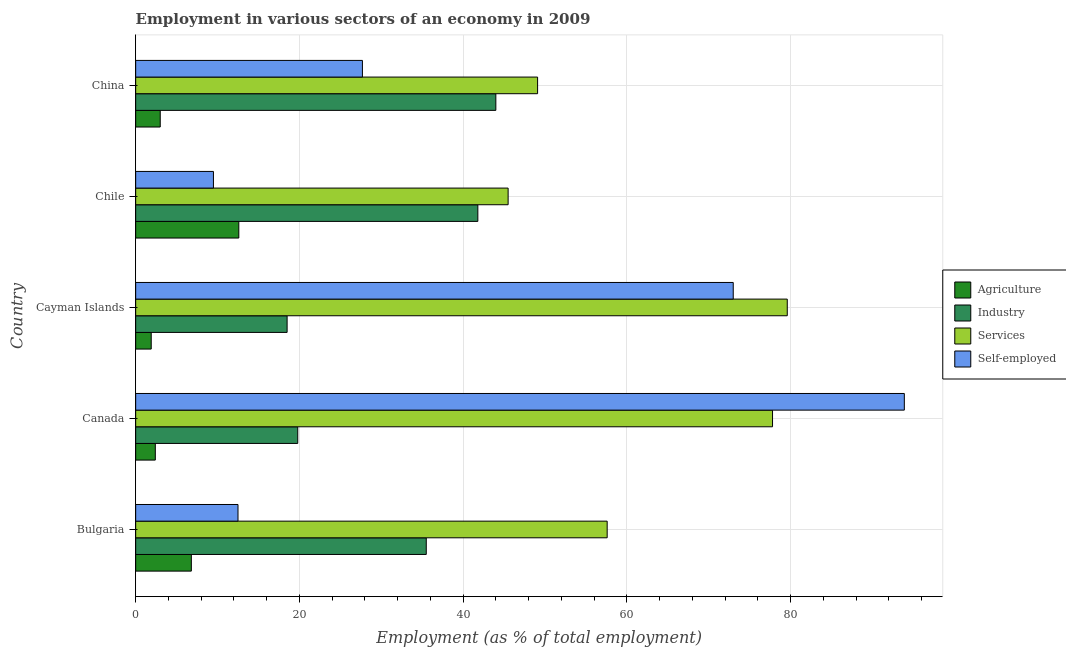How many groups of bars are there?
Offer a very short reply. 5. How many bars are there on the 3rd tick from the top?
Provide a succinct answer. 4. How many bars are there on the 2nd tick from the bottom?
Provide a succinct answer. 4. In how many cases, is the number of bars for a given country not equal to the number of legend labels?
Make the answer very short. 0. What is the percentage of workers in industry in China?
Offer a very short reply. 44. Across all countries, what is the maximum percentage of workers in services?
Your answer should be compact. 79.6. Across all countries, what is the minimum percentage of workers in agriculture?
Provide a succinct answer. 1.9. What is the total percentage of self employed workers in the graph?
Make the answer very short. 216.6. What is the difference between the percentage of workers in industry in Bulgaria and the percentage of self employed workers in Canada?
Offer a terse response. -58.4. What is the average percentage of workers in industry per country?
Your answer should be compact. 31.92. What is the difference between the percentage of workers in agriculture and percentage of self employed workers in Canada?
Your response must be concise. -91.5. What is the ratio of the percentage of self employed workers in Bulgaria to that in China?
Offer a very short reply. 0.45. Is the difference between the percentage of workers in industry in Cayman Islands and China greater than the difference between the percentage of workers in agriculture in Cayman Islands and China?
Make the answer very short. No. In how many countries, is the percentage of workers in industry greater than the average percentage of workers in industry taken over all countries?
Make the answer very short. 3. Is the sum of the percentage of workers in services in Bulgaria and Canada greater than the maximum percentage of workers in agriculture across all countries?
Provide a short and direct response. Yes. Is it the case that in every country, the sum of the percentage of workers in services and percentage of self employed workers is greater than the sum of percentage of workers in industry and percentage of workers in agriculture?
Make the answer very short. Yes. What does the 1st bar from the top in Cayman Islands represents?
Your answer should be very brief. Self-employed. What does the 3rd bar from the bottom in Bulgaria represents?
Your answer should be compact. Services. How many bars are there?
Offer a very short reply. 20. How many countries are there in the graph?
Offer a terse response. 5. How many legend labels are there?
Offer a very short reply. 4. What is the title of the graph?
Keep it short and to the point. Employment in various sectors of an economy in 2009. What is the label or title of the X-axis?
Offer a terse response. Employment (as % of total employment). What is the Employment (as % of total employment) in Agriculture in Bulgaria?
Make the answer very short. 6.8. What is the Employment (as % of total employment) of Industry in Bulgaria?
Offer a very short reply. 35.5. What is the Employment (as % of total employment) in Services in Bulgaria?
Your answer should be compact. 57.6. What is the Employment (as % of total employment) in Self-employed in Bulgaria?
Keep it short and to the point. 12.5. What is the Employment (as % of total employment) in Agriculture in Canada?
Provide a short and direct response. 2.4. What is the Employment (as % of total employment) in Industry in Canada?
Make the answer very short. 19.8. What is the Employment (as % of total employment) of Services in Canada?
Your answer should be compact. 77.8. What is the Employment (as % of total employment) in Self-employed in Canada?
Offer a terse response. 93.9. What is the Employment (as % of total employment) in Agriculture in Cayman Islands?
Provide a succinct answer. 1.9. What is the Employment (as % of total employment) of Services in Cayman Islands?
Your answer should be compact. 79.6. What is the Employment (as % of total employment) of Agriculture in Chile?
Your answer should be very brief. 12.6. What is the Employment (as % of total employment) in Industry in Chile?
Provide a short and direct response. 41.8. What is the Employment (as % of total employment) of Services in Chile?
Offer a terse response. 45.5. What is the Employment (as % of total employment) of Industry in China?
Ensure brevity in your answer.  44. What is the Employment (as % of total employment) of Services in China?
Make the answer very short. 49.1. What is the Employment (as % of total employment) in Self-employed in China?
Provide a succinct answer. 27.7. Across all countries, what is the maximum Employment (as % of total employment) of Agriculture?
Make the answer very short. 12.6. Across all countries, what is the maximum Employment (as % of total employment) in Services?
Make the answer very short. 79.6. Across all countries, what is the maximum Employment (as % of total employment) of Self-employed?
Provide a short and direct response. 93.9. Across all countries, what is the minimum Employment (as % of total employment) in Agriculture?
Offer a very short reply. 1.9. Across all countries, what is the minimum Employment (as % of total employment) in Industry?
Offer a very short reply. 18.5. Across all countries, what is the minimum Employment (as % of total employment) of Services?
Provide a short and direct response. 45.5. What is the total Employment (as % of total employment) of Agriculture in the graph?
Make the answer very short. 26.7. What is the total Employment (as % of total employment) in Industry in the graph?
Offer a terse response. 159.6. What is the total Employment (as % of total employment) in Services in the graph?
Give a very brief answer. 309.6. What is the total Employment (as % of total employment) of Self-employed in the graph?
Offer a terse response. 216.6. What is the difference between the Employment (as % of total employment) in Agriculture in Bulgaria and that in Canada?
Ensure brevity in your answer.  4.4. What is the difference between the Employment (as % of total employment) of Industry in Bulgaria and that in Canada?
Keep it short and to the point. 15.7. What is the difference between the Employment (as % of total employment) in Services in Bulgaria and that in Canada?
Offer a terse response. -20.2. What is the difference between the Employment (as % of total employment) of Self-employed in Bulgaria and that in Canada?
Your answer should be very brief. -81.4. What is the difference between the Employment (as % of total employment) of Self-employed in Bulgaria and that in Cayman Islands?
Keep it short and to the point. -60.5. What is the difference between the Employment (as % of total employment) of Industry in Bulgaria and that in Chile?
Give a very brief answer. -6.3. What is the difference between the Employment (as % of total employment) in Self-employed in Bulgaria and that in Chile?
Your answer should be compact. 3. What is the difference between the Employment (as % of total employment) in Industry in Bulgaria and that in China?
Offer a very short reply. -8.5. What is the difference between the Employment (as % of total employment) in Services in Bulgaria and that in China?
Provide a succinct answer. 8.5. What is the difference between the Employment (as % of total employment) in Self-employed in Bulgaria and that in China?
Offer a terse response. -15.2. What is the difference between the Employment (as % of total employment) in Industry in Canada and that in Cayman Islands?
Offer a very short reply. 1.3. What is the difference between the Employment (as % of total employment) of Services in Canada and that in Cayman Islands?
Keep it short and to the point. -1.8. What is the difference between the Employment (as % of total employment) in Self-employed in Canada and that in Cayman Islands?
Your answer should be compact. 20.9. What is the difference between the Employment (as % of total employment) in Agriculture in Canada and that in Chile?
Provide a succinct answer. -10.2. What is the difference between the Employment (as % of total employment) of Industry in Canada and that in Chile?
Offer a very short reply. -22. What is the difference between the Employment (as % of total employment) in Services in Canada and that in Chile?
Keep it short and to the point. 32.3. What is the difference between the Employment (as % of total employment) in Self-employed in Canada and that in Chile?
Ensure brevity in your answer.  84.4. What is the difference between the Employment (as % of total employment) of Industry in Canada and that in China?
Make the answer very short. -24.2. What is the difference between the Employment (as % of total employment) of Services in Canada and that in China?
Offer a terse response. 28.7. What is the difference between the Employment (as % of total employment) of Self-employed in Canada and that in China?
Ensure brevity in your answer.  66.2. What is the difference between the Employment (as % of total employment) of Industry in Cayman Islands and that in Chile?
Your answer should be compact. -23.3. What is the difference between the Employment (as % of total employment) in Services in Cayman Islands and that in Chile?
Your answer should be very brief. 34.1. What is the difference between the Employment (as % of total employment) in Self-employed in Cayman Islands and that in Chile?
Your response must be concise. 63.5. What is the difference between the Employment (as % of total employment) in Agriculture in Cayman Islands and that in China?
Offer a terse response. -1.1. What is the difference between the Employment (as % of total employment) in Industry in Cayman Islands and that in China?
Provide a succinct answer. -25.5. What is the difference between the Employment (as % of total employment) in Services in Cayman Islands and that in China?
Give a very brief answer. 30.5. What is the difference between the Employment (as % of total employment) in Self-employed in Cayman Islands and that in China?
Offer a terse response. 45.3. What is the difference between the Employment (as % of total employment) of Services in Chile and that in China?
Offer a terse response. -3.6. What is the difference between the Employment (as % of total employment) of Self-employed in Chile and that in China?
Offer a terse response. -18.2. What is the difference between the Employment (as % of total employment) of Agriculture in Bulgaria and the Employment (as % of total employment) of Industry in Canada?
Provide a short and direct response. -13. What is the difference between the Employment (as % of total employment) of Agriculture in Bulgaria and the Employment (as % of total employment) of Services in Canada?
Provide a short and direct response. -71. What is the difference between the Employment (as % of total employment) in Agriculture in Bulgaria and the Employment (as % of total employment) in Self-employed in Canada?
Your answer should be compact. -87.1. What is the difference between the Employment (as % of total employment) of Industry in Bulgaria and the Employment (as % of total employment) of Services in Canada?
Keep it short and to the point. -42.3. What is the difference between the Employment (as % of total employment) in Industry in Bulgaria and the Employment (as % of total employment) in Self-employed in Canada?
Provide a short and direct response. -58.4. What is the difference between the Employment (as % of total employment) in Services in Bulgaria and the Employment (as % of total employment) in Self-employed in Canada?
Your answer should be compact. -36.3. What is the difference between the Employment (as % of total employment) in Agriculture in Bulgaria and the Employment (as % of total employment) in Services in Cayman Islands?
Offer a very short reply. -72.8. What is the difference between the Employment (as % of total employment) in Agriculture in Bulgaria and the Employment (as % of total employment) in Self-employed in Cayman Islands?
Offer a very short reply. -66.2. What is the difference between the Employment (as % of total employment) of Industry in Bulgaria and the Employment (as % of total employment) of Services in Cayman Islands?
Your answer should be very brief. -44.1. What is the difference between the Employment (as % of total employment) of Industry in Bulgaria and the Employment (as % of total employment) of Self-employed in Cayman Islands?
Give a very brief answer. -37.5. What is the difference between the Employment (as % of total employment) in Services in Bulgaria and the Employment (as % of total employment) in Self-employed in Cayman Islands?
Offer a very short reply. -15.4. What is the difference between the Employment (as % of total employment) in Agriculture in Bulgaria and the Employment (as % of total employment) in Industry in Chile?
Keep it short and to the point. -35. What is the difference between the Employment (as % of total employment) of Agriculture in Bulgaria and the Employment (as % of total employment) of Services in Chile?
Your response must be concise. -38.7. What is the difference between the Employment (as % of total employment) in Industry in Bulgaria and the Employment (as % of total employment) in Services in Chile?
Provide a short and direct response. -10. What is the difference between the Employment (as % of total employment) of Industry in Bulgaria and the Employment (as % of total employment) of Self-employed in Chile?
Your response must be concise. 26. What is the difference between the Employment (as % of total employment) in Services in Bulgaria and the Employment (as % of total employment) in Self-employed in Chile?
Provide a short and direct response. 48.1. What is the difference between the Employment (as % of total employment) in Agriculture in Bulgaria and the Employment (as % of total employment) in Industry in China?
Provide a short and direct response. -37.2. What is the difference between the Employment (as % of total employment) in Agriculture in Bulgaria and the Employment (as % of total employment) in Services in China?
Offer a terse response. -42.3. What is the difference between the Employment (as % of total employment) in Agriculture in Bulgaria and the Employment (as % of total employment) in Self-employed in China?
Your answer should be compact. -20.9. What is the difference between the Employment (as % of total employment) of Services in Bulgaria and the Employment (as % of total employment) of Self-employed in China?
Your answer should be compact. 29.9. What is the difference between the Employment (as % of total employment) in Agriculture in Canada and the Employment (as % of total employment) in Industry in Cayman Islands?
Give a very brief answer. -16.1. What is the difference between the Employment (as % of total employment) of Agriculture in Canada and the Employment (as % of total employment) of Services in Cayman Islands?
Your answer should be very brief. -77.2. What is the difference between the Employment (as % of total employment) of Agriculture in Canada and the Employment (as % of total employment) of Self-employed in Cayman Islands?
Offer a very short reply. -70.6. What is the difference between the Employment (as % of total employment) in Industry in Canada and the Employment (as % of total employment) in Services in Cayman Islands?
Your answer should be very brief. -59.8. What is the difference between the Employment (as % of total employment) of Industry in Canada and the Employment (as % of total employment) of Self-employed in Cayman Islands?
Offer a very short reply. -53.2. What is the difference between the Employment (as % of total employment) of Services in Canada and the Employment (as % of total employment) of Self-employed in Cayman Islands?
Ensure brevity in your answer.  4.8. What is the difference between the Employment (as % of total employment) in Agriculture in Canada and the Employment (as % of total employment) in Industry in Chile?
Your answer should be very brief. -39.4. What is the difference between the Employment (as % of total employment) in Agriculture in Canada and the Employment (as % of total employment) in Services in Chile?
Offer a very short reply. -43.1. What is the difference between the Employment (as % of total employment) of Industry in Canada and the Employment (as % of total employment) of Services in Chile?
Provide a succinct answer. -25.7. What is the difference between the Employment (as % of total employment) of Industry in Canada and the Employment (as % of total employment) of Self-employed in Chile?
Provide a short and direct response. 10.3. What is the difference between the Employment (as % of total employment) in Services in Canada and the Employment (as % of total employment) in Self-employed in Chile?
Provide a succinct answer. 68.3. What is the difference between the Employment (as % of total employment) in Agriculture in Canada and the Employment (as % of total employment) in Industry in China?
Your answer should be very brief. -41.6. What is the difference between the Employment (as % of total employment) of Agriculture in Canada and the Employment (as % of total employment) of Services in China?
Give a very brief answer. -46.7. What is the difference between the Employment (as % of total employment) in Agriculture in Canada and the Employment (as % of total employment) in Self-employed in China?
Keep it short and to the point. -25.3. What is the difference between the Employment (as % of total employment) in Industry in Canada and the Employment (as % of total employment) in Services in China?
Ensure brevity in your answer.  -29.3. What is the difference between the Employment (as % of total employment) of Services in Canada and the Employment (as % of total employment) of Self-employed in China?
Keep it short and to the point. 50.1. What is the difference between the Employment (as % of total employment) in Agriculture in Cayman Islands and the Employment (as % of total employment) in Industry in Chile?
Provide a short and direct response. -39.9. What is the difference between the Employment (as % of total employment) in Agriculture in Cayman Islands and the Employment (as % of total employment) in Services in Chile?
Give a very brief answer. -43.6. What is the difference between the Employment (as % of total employment) of Industry in Cayman Islands and the Employment (as % of total employment) of Services in Chile?
Your answer should be compact. -27. What is the difference between the Employment (as % of total employment) in Industry in Cayman Islands and the Employment (as % of total employment) in Self-employed in Chile?
Keep it short and to the point. 9. What is the difference between the Employment (as % of total employment) of Services in Cayman Islands and the Employment (as % of total employment) of Self-employed in Chile?
Provide a succinct answer. 70.1. What is the difference between the Employment (as % of total employment) of Agriculture in Cayman Islands and the Employment (as % of total employment) of Industry in China?
Provide a succinct answer. -42.1. What is the difference between the Employment (as % of total employment) of Agriculture in Cayman Islands and the Employment (as % of total employment) of Services in China?
Make the answer very short. -47.2. What is the difference between the Employment (as % of total employment) in Agriculture in Cayman Islands and the Employment (as % of total employment) in Self-employed in China?
Provide a short and direct response. -25.8. What is the difference between the Employment (as % of total employment) in Industry in Cayman Islands and the Employment (as % of total employment) in Services in China?
Your answer should be compact. -30.6. What is the difference between the Employment (as % of total employment) of Services in Cayman Islands and the Employment (as % of total employment) of Self-employed in China?
Your response must be concise. 51.9. What is the difference between the Employment (as % of total employment) in Agriculture in Chile and the Employment (as % of total employment) in Industry in China?
Ensure brevity in your answer.  -31.4. What is the difference between the Employment (as % of total employment) in Agriculture in Chile and the Employment (as % of total employment) in Services in China?
Your response must be concise. -36.5. What is the difference between the Employment (as % of total employment) in Agriculture in Chile and the Employment (as % of total employment) in Self-employed in China?
Keep it short and to the point. -15.1. What is the difference between the Employment (as % of total employment) of Industry in Chile and the Employment (as % of total employment) of Services in China?
Offer a very short reply. -7.3. What is the average Employment (as % of total employment) of Agriculture per country?
Offer a terse response. 5.34. What is the average Employment (as % of total employment) in Industry per country?
Your response must be concise. 31.92. What is the average Employment (as % of total employment) of Services per country?
Your response must be concise. 61.92. What is the average Employment (as % of total employment) in Self-employed per country?
Your answer should be compact. 43.32. What is the difference between the Employment (as % of total employment) of Agriculture and Employment (as % of total employment) of Industry in Bulgaria?
Ensure brevity in your answer.  -28.7. What is the difference between the Employment (as % of total employment) in Agriculture and Employment (as % of total employment) in Services in Bulgaria?
Your answer should be compact. -50.8. What is the difference between the Employment (as % of total employment) of Agriculture and Employment (as % of total employment) of Self-employed in Bulgaria?
Provide a succinct answer. -5.7. What is the difference between the Employment (as % of total employment) of Industry and Employment (as % of total employment) of Services in Bulgaria?
Ensure brevity in your answer.  -22.1. What is the difference between the Employment (as % of total employment) in Services and Employment (as % of total employment) in Self-employed in Bulgaria?
Your response must be concise. 45.1. What is the difference between the Employment (as % of total employment) of Agriculture and Employment (as % of total employment) of Industry in Canada?
Keep it short and to the point. -17.4. What is the difference between the Employment (as % of total employment) of Agriculture and Employment (as % of total employment) of Services in Canada?
Provide a succinct answer. -75.4. What is the difference between the Employment (as % of total employment) in Agriculture and Employment (as % of total employment) in Self-employed in Canada?
Provide a succinct answer. -91.5. What is the difference between the Employment (as % of total employment) in Industry and Employment (as % of total employment) in Services in Canada?
Make the answer very short. -58. What is the difference between the Employment (as % of total employment) in Industry and Employment (as % of total employment) in Self-employed in Canada?
Your answer should be compact. -74.1. What is the difference between the Employment (as % of total employment) of Services and Employment (as % of total employment) of Self-employed in Canada?
Give a very brief answer. -16.1. What is the difference between the Employment (as % of total employment) in Agriculture and Employment (as % of total employment) in Industry in Cayman Islands?
Your answer should be compact. -16.6. What is the difference between the Employment (as % of total employment) of Agriculture and Employment (as % of total employment) of Services in Cayman Islands?
Your answer should be compact. -77.7. What is the difference between the Employment (as % of total employment) in Agriculture and Employment (as % of total employment) in Self-employed in Cayman Islands?
Keep it short and to the point. -71.1. What is the difference between the Employment (as % of total employment) of Industry and Employment (as % of total employment) of Services in Cayman Islands?
Ensure brevity in your answer.  -61.1. What is the difference between the Employment (as % of total employment) in Industry and Employment (as % of total employment) in Self-employed in Cayman Islands?
Give a very brief answer. -54.5. What is the difference between the Employment (as % of total employment) of Agriculture and Employment (as % of total employment) of Industry in Chile?
Provide a short and direct response. -29.2. What is the difference between the Employment (as % of total employment) in Agriculture and Employment (as % of total employment) in Services in Chile?
Provide a short and direct response. -32.9. What is the difference between the Employment (as % of total employment) of Industry and Employment (as % of total employment) of Services in Chile?
Give a very brief answer. -3.7. What is the difference between the Employment (as % of total employment) in Industry and Employment (as % of total employment) in Self-employed in Chile?
Your answer should be very brief. 32.3. What is the difference between the Employment (as % of total employment) in Services and Employment (as % of total employment) in Self-employed in Chile?
Ensure brevity in your answer.  36. What is the difference between the Employment (as % of total employment) in Agriculture and Employment (as % of total employment) in Industry in China?
Ensure brevity in your answer.  -41. What is the difference between the Employment (as % of total employment) of Agriculture and Employment (as % of total employment) of Services in China?
Keep it short and to the point. -46.1. What is the difference between the Employment (as % of total employment) of Agriculture and Employment (as % of total employment) of Self-employed in China?
Offer a very short reply. -24.7. What is the difference between the Employment (as % of total employment) of Services and Employment (as % of total employment) of Self-employed in China?
Keep it short and to the point. 21.4. What is the ratio of the Employment (as % of total employment) of Agriculture in Bulgaria to that in Canada?
Provide a succinct answer. 2.83. What is the ratio of the Employment (as % of total employment) in Industry in Bulgaria to that in Canada?
Make the answer very short. 1.79. What is the ratio of the Employment (as % of total employment) in Services in Bulgaria to that in Canada?
Give a very brief answer. 0.74. What is the ratio of the Employment (as % of total employment) of Self-employed in Bulgaria to that in Canada?
Provide a short and direct response. 0.13. What is the ratio of the Employment (as % of total employment) of Agriculture in Bulgaria to that in Cayman Islands?
Offer a terse response. 3.58. What is the ratio of the Employment (as % of total employment) of Industry in Bulgaria to that in Cayman Islands?
Provide a short and direct response. 1.92. What is the ratio of the Employment (as % of total employment) in Services in Bulgaria to that in Cayman Islands?
Your response must be concise. 0.72. What is the ratio of the Employment (as % of total employment) of Self-employed in Bulgaria to that in Cayman Islands?
Provide a short and direct response. 0.17. What is the ratio of the Employment (as % of total employment) of Agriculture in Bulgaria to that in Chile?
Your response must be concise. 0.54. What is the ratio of the Employment (as % of total employment) in Industry in Bulgaria to that in Chile?
Provide a short and direct response. 0.85. What is the ratio of the Employment (as % of total employment) of Services in Bulgaria to that in Chile?
Provide a succinct answer. 1.27. What is the ratio of the Employment (as % of total employment) in Self-employed in Bulgaria to that in Chile?
Give a very brief answer. 1.32. What is the ratio of the Employment (as % of total employment) of Agriculture in Bulgaria to that in China?
Your response must be concise. 2.27. What is the ratio of the Employment (as % of total employment) of Industry in Bulgaria to that in China?
Offer a terse response. 0.81. What is the ratio of the Employment (as % of total employment) of Services in Bulgaria to that in China?
Your response must be concise. 1.17. What is the ratio of the Employment (as % of total employment) in Self-employed in Bulgaria to that in China?
Offer a terse response. 0.45. What is the ratio of the Employment (as % of total employment) in Agriculture in Canada to that in Cayman Islands?
Provide a short and direct response. 1.26. What is the ratio of the Employment (as % of total employment) of Industry in Canada to that in Cayman Islands?
Provide a succinct answer. 1.07. What is the ratio of the Employment (as % of total employment) in Services in Canada to that in Cayman Islands?
Make the answer very short. 0.98. What is the ratio of the Employment (as % of total employment) in Self-employed in Canada to that in Cayman Islands?
Offer a terse response. 1.29. What is the ratio of the Employment (as % of total employment) of Agriculture in Canada to that in Chile?
Your answer should be very brief. 0.19. What is the ratio of the Employment (as % of total employment) of Industry in Canada to that in Chile?
Keep it short and to the point. 0.47. What is the ratio of the Employment (as % of total employment) in Services in Canada to that in Chile?
Provide a succinct answer. 1.71. What is the ratio of the Employment (as % of total employment) in Self-employed in Canada to that in Chile?
Make the answer very short. 9.88. What is the ratio of the Employment (as % of total employment) of Industry in Canada to that in China?
Make the answer very short. 0.45. What is the ratio of the Employment (as % of total employment) in Services in Canada to that in China?
Provide a short and direct response. 1.58. What is the ratio of the Employment (as % of total employment) in Self-employed in Canada to that in China?
Your answer should be very brief. 3.39. What is the ratio of the Employment (as % of total employment) of Agriculture in Cayman Islands to that in Chile?
Give a very brief answer. 0.15. What is the ratio of the Employment (as % of total employment) of Industry in Cayman Islands to that in Chile?
Offer a very short reply. 0.44. What is the ratio of the Employment (as % of total employment) in Services in Cayman Islands to that in Chile?
Make the answer very short. 1.75. What is the ratio of the Employment (as % of total employment) in Self-employed in Cayman Islands to that in Chile?
Give a very brief answer. 7.68. What is the ratio of the Employment (as % of total employment) in Agriculture in Cayman Islands to that in China?
Keep it short and to the point. 0.63. What is the ratio of the Employment (as % of total employment) in Industry in Cayman Islands to that in China?
Keep it short and to the point. 0.42. What is the ratio of the Employment (as % of total employment) in Services in Cayman Islands to that in China?
Your answer should be compact. 1.62. What is the ratio of the Employment (as % of total employment) in Self-employed in Cayman Islands to that in China?
Your answer should be very brief. 2.64. What is the ratio of the Employment (as % of total employment) in Services in Chile to that in China?
Your response must be concise. 0.93. What is the ratio of the Employment (as % of total employment) of Self-employed in Chile to that in China?
Your response must be concise. 0.34. What is the difference between the highest and the second highest Employment (as % of total employment) of Agriculture?
Offer a very short reply. 5.8. What is the difference between the highest and the second highest Employment (as % of total employment) in Self-employed?
Your response must be concise. 20.9. What is the difference between the highest and the lowest Employment (as % of total employment) in Industry?
Offer a terse response. 25.5. What is the difference between the highest and the lowest Employment (as % of total employment) of Services?
Provide a succinct answer. 34.1. What is the difference between the highest and the lowest Employment (as % of total employment) of Self-employed?
Keep it short and to the point. 84.4. 